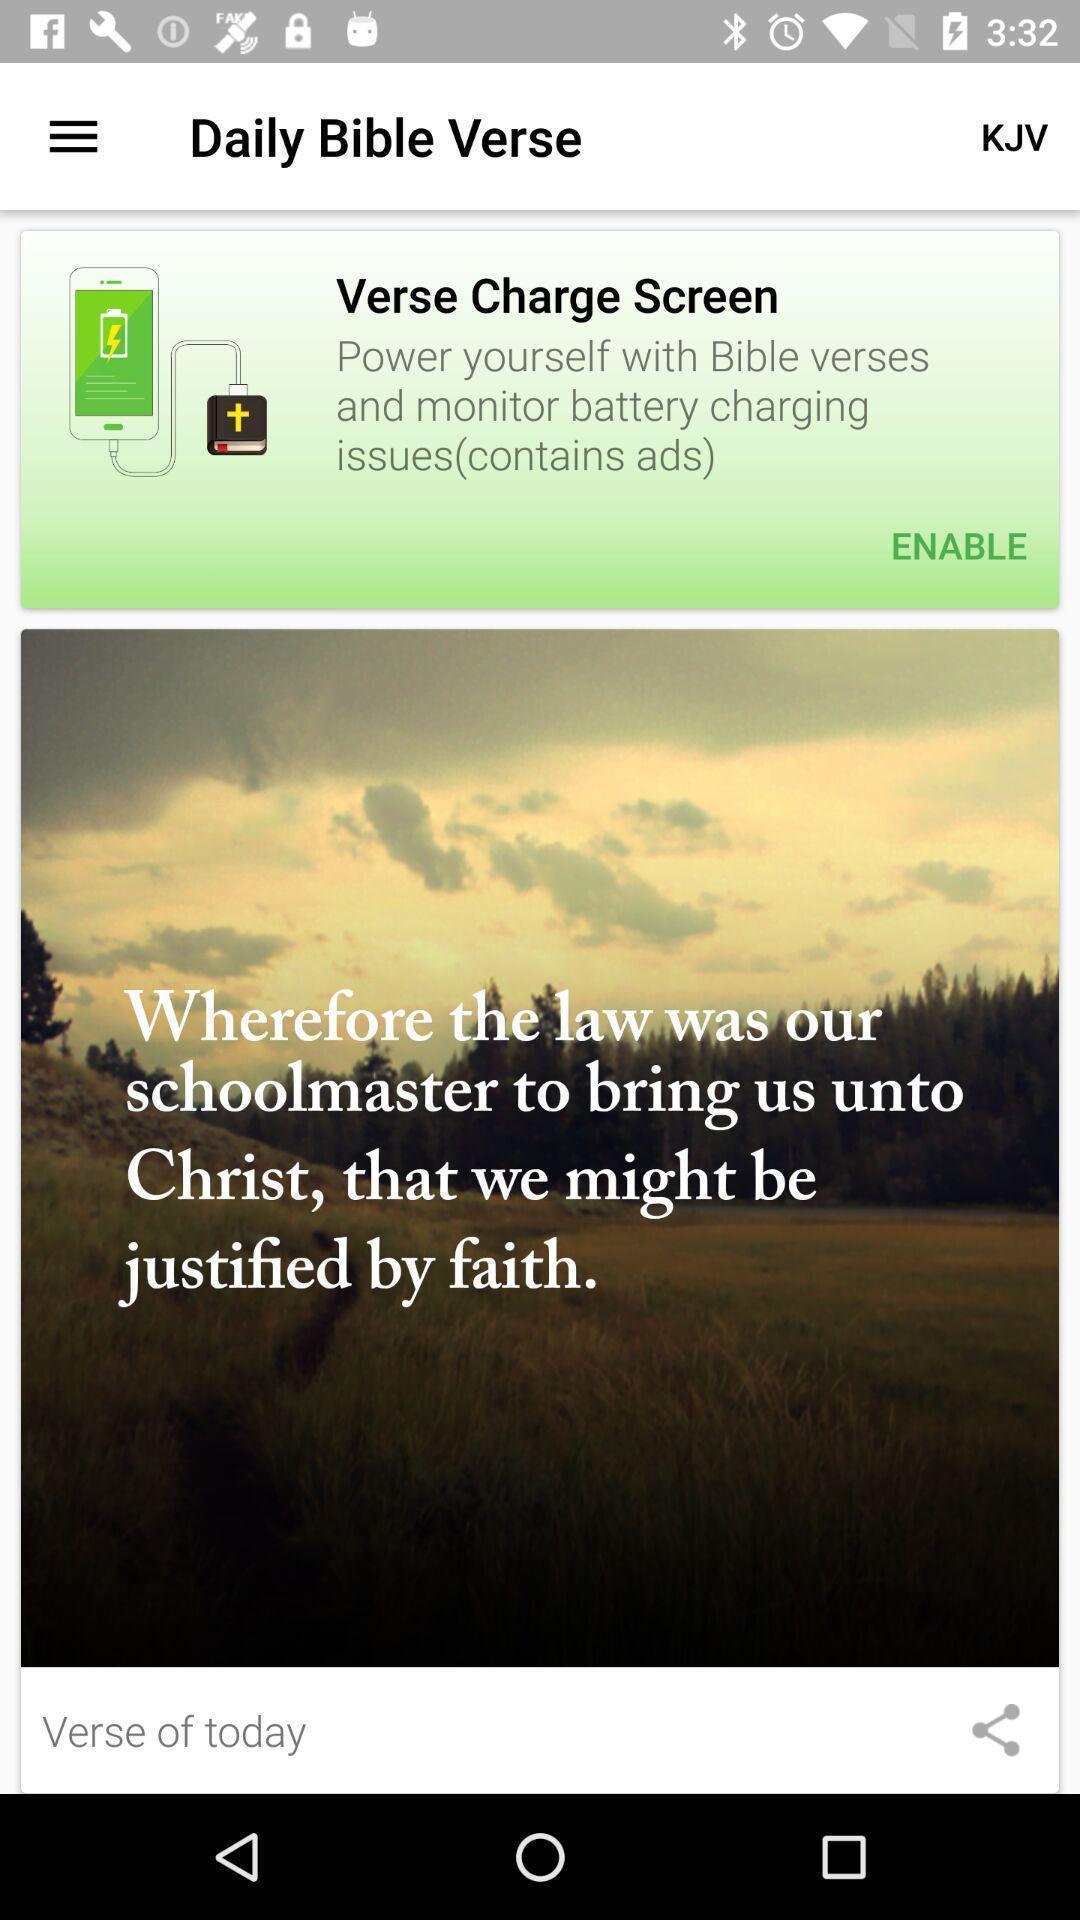Provide a detailed account of this screenshot. Page of a holy book application with sharing option. 